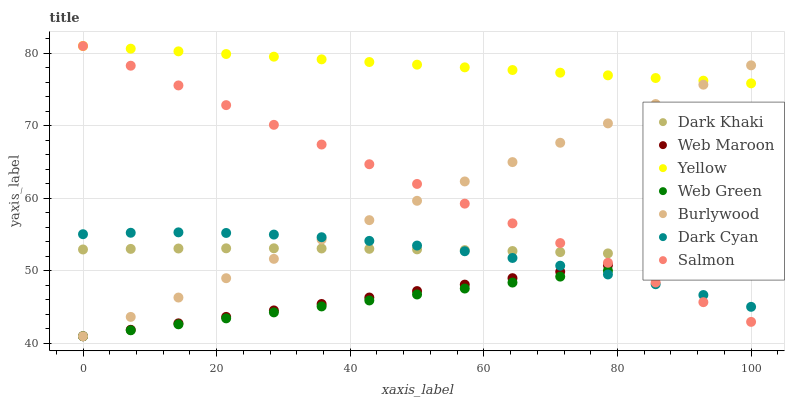Does Web Green have the minimum area under the curve?
Answer yes or no. Yes. Does Yellow have the maximum area under the curve?
Answer yes or no. Yes. Does Salmon have the minimum area under the curve?
Answer yes or no. No. Does Salmon have the maximum area under the curve?
Answer yes or no. No. Is Burlywood the smoothest?
Answer yes or no. Yes. Is Dark Cyan the roughest?
Answer yes or no. Yes. Is Salmon the smoothest?
Answer yes or no. No. Is Salmon the roughest?
Answer yes or no. No. Does Burlywood have the lowest value?
Answer yes or no. Yes. Does Salmon have the lowest value?
Answer yes or no. No. Does Yellow have the highest value?
Answer yes or no. Yes. Does Web Maroon have the highest value?
Answer yes or no. No. Is Web Green less than Yellow?
Answer yes or no. Yes. Is Yellow greater than Web Maroon?
Answer yes or no. Yes. Does Salmon intersect Dark Khaki?
Answer yes or no. Yes. Is Salmon less than Dark Khaki?
Answer yes or no. No. Is Salmon greater than Dark Khaki?
Answer yes or no. No. Does Web Green intersect Yellow?
Answer yes or no. No. 